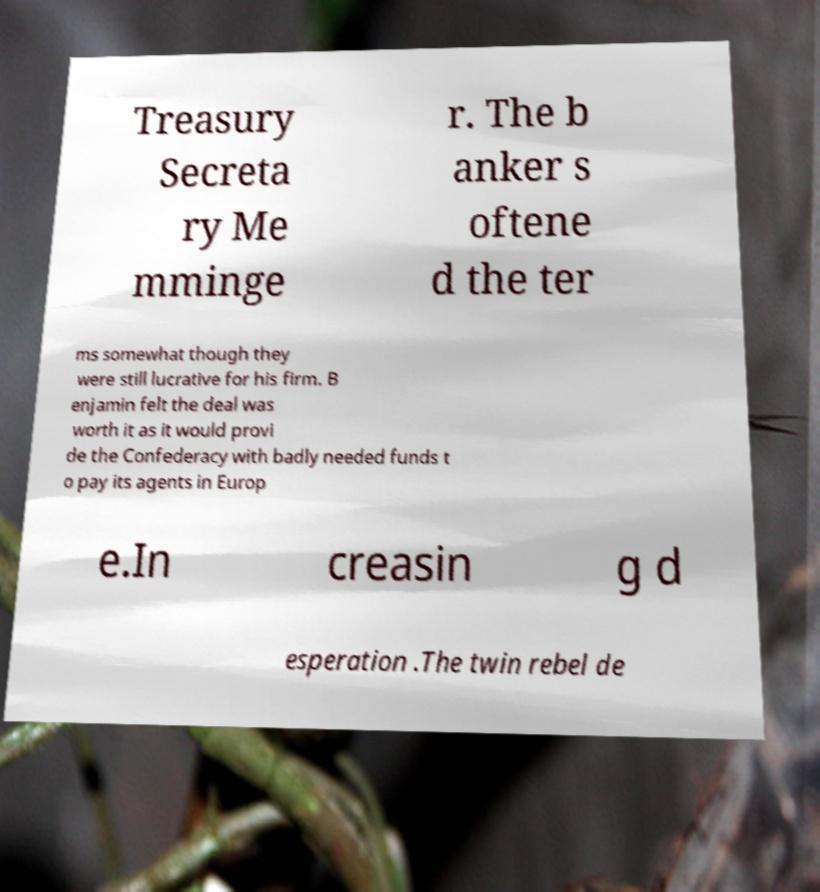I need the written content from this picture converted into text. Can you do that? Treasury Secreta ry Me mminge r. The b anker s oftene d the ter ms somewhat though they were still lucrative for his firm. B enjamin felt the deal was worth it as it would provi de the Confederacy with badly needed funds t o pay its agents in Europ e.In creasin g d esperation .The twin rebel de 